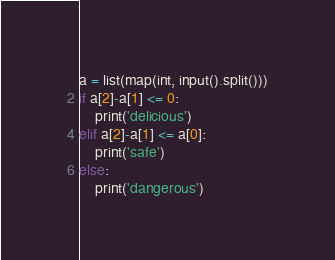Convert code to text. <code><loc_0><loc_0><loc_500><loc_500><_Python_>a = list(map(int, input().split()))
if a[2]-a[1] <= 0:
	print('delicious')
elif a[2]-a[1] <= a[0]:
	print('safe')
else:
	print('dangerous')</code> 